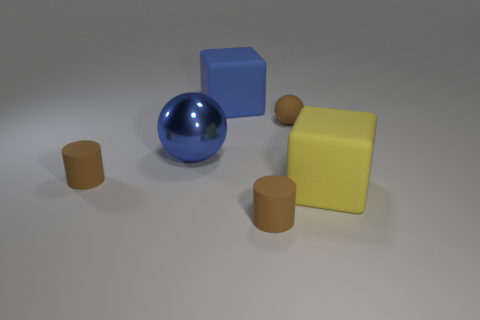What shape is the large yellow rubber thing?
Keep it short and to the point. Cube. Are there any blue metal objects to the right of the brown matte cylinder that is to the right of the large blue matte thing that is behind the tiny ball?
Your answer should be compact. No. There is a cylinder that is behind the brown rubber cylinder in front of the matte cube right of the tiny ball; what color is it?
Keep it short and to the point. Brown. What is the material of the blue thing that is the same shape as the yellow thing?
Make the answer very short. Rubber. There is a brown thing that is in front of the tiny brown rubber cylinder left of the large blue metal sphere; what size is it?
Offer a terse response. Small. What material is the block in front of the tiny matte sphere?
Your answer should be compact. Rubber. There is a sphere that is made of the same material as the yellow block; what is its size?
Provide a short and direct response. Small. How many other objects are the same shape as the yellow rubber thing?
Your response must be concise. 1. There is a big yellow matte object; does it have the same shape as the brown matte object behind the big metallic ball?
Provide a short and direct response. No. What shape is the other big object that is the same color as the large metallic thing?
Ensure brevity in your answer.  Cube. 